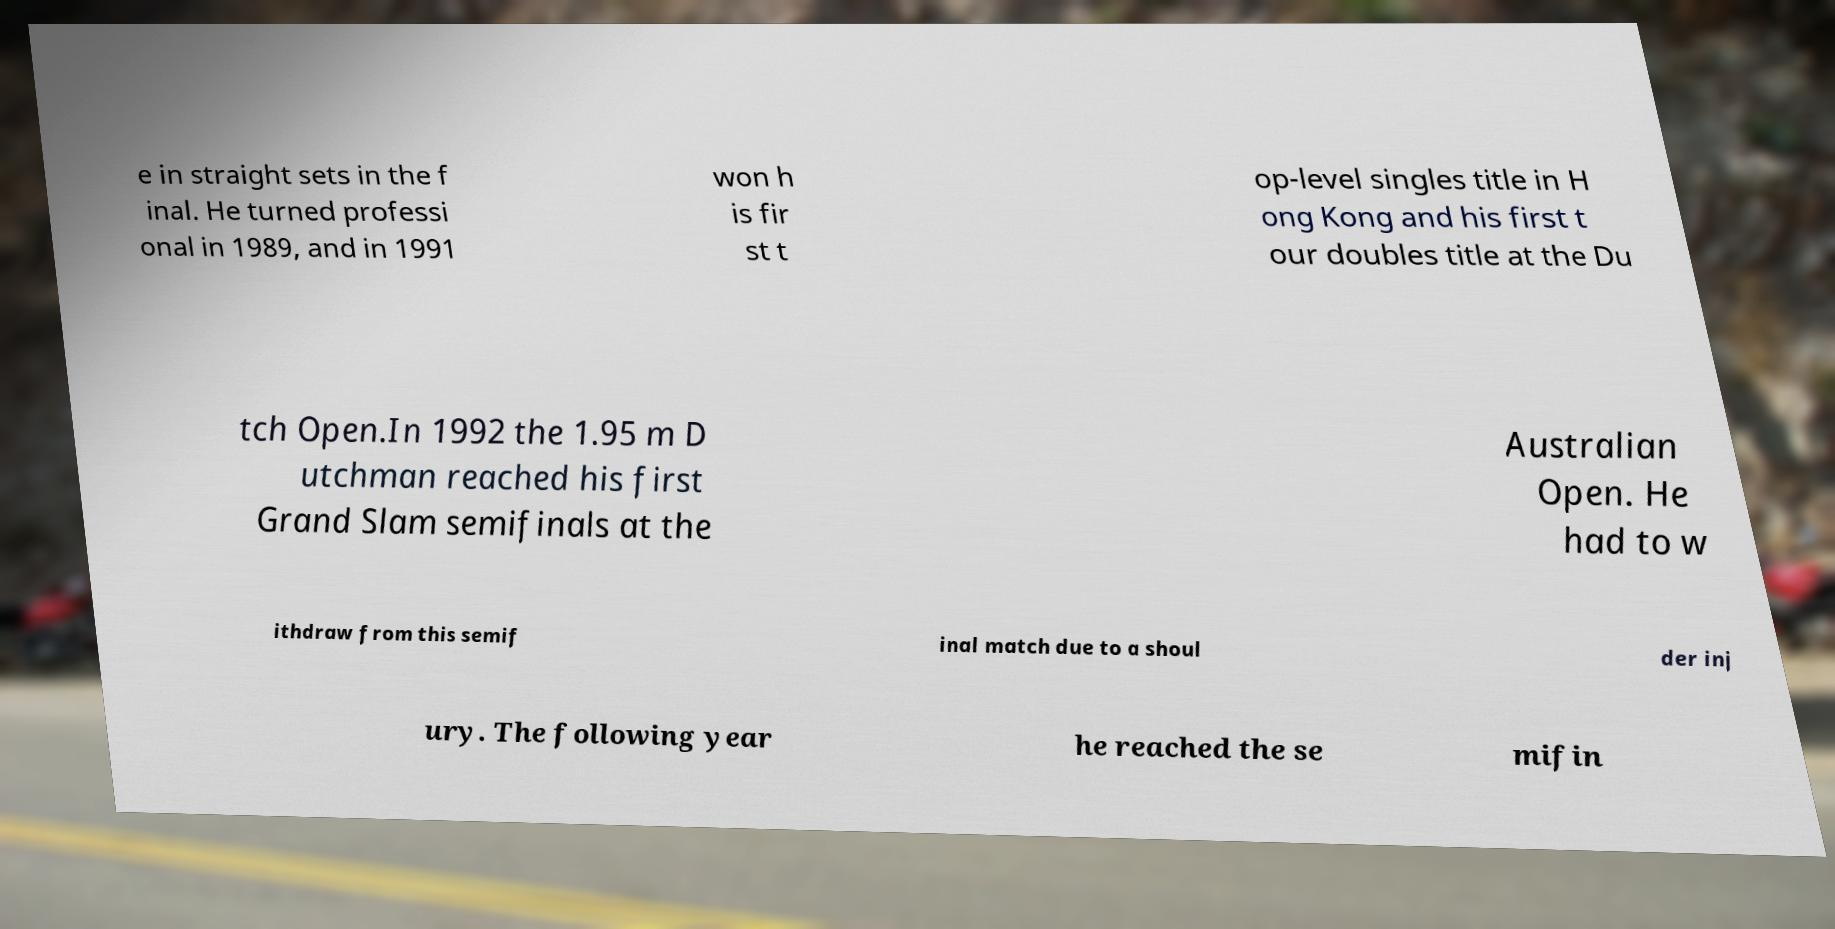For documentation purposes, I need the text within this image transcribed. Could you provide that? e in straight sets in the f inal. He turned professi onal in 1989, and in 1991 won h is fir st t op-level singles title in H ong Kong and his first t our doubles title at the Du tch Open.In 1992 the 1.95 m D utchman reached his first Grand Slam semifinals at the Australian Open. He had to w ithdraw from this semif inal match due to a shoul der inj ury. The following year he reached the se mifin 